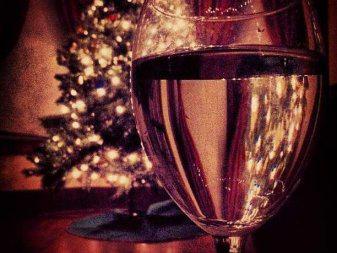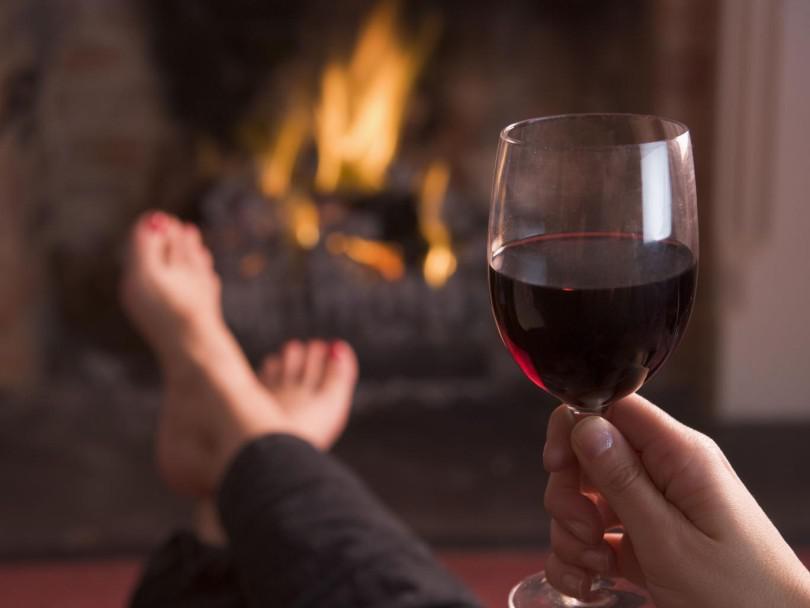The first image is the image on the left, the second image is the image on the right. For the images shown, is this caption "The left image shows burgundy wine pouring into a glass." true? Answer yes or no. No. 